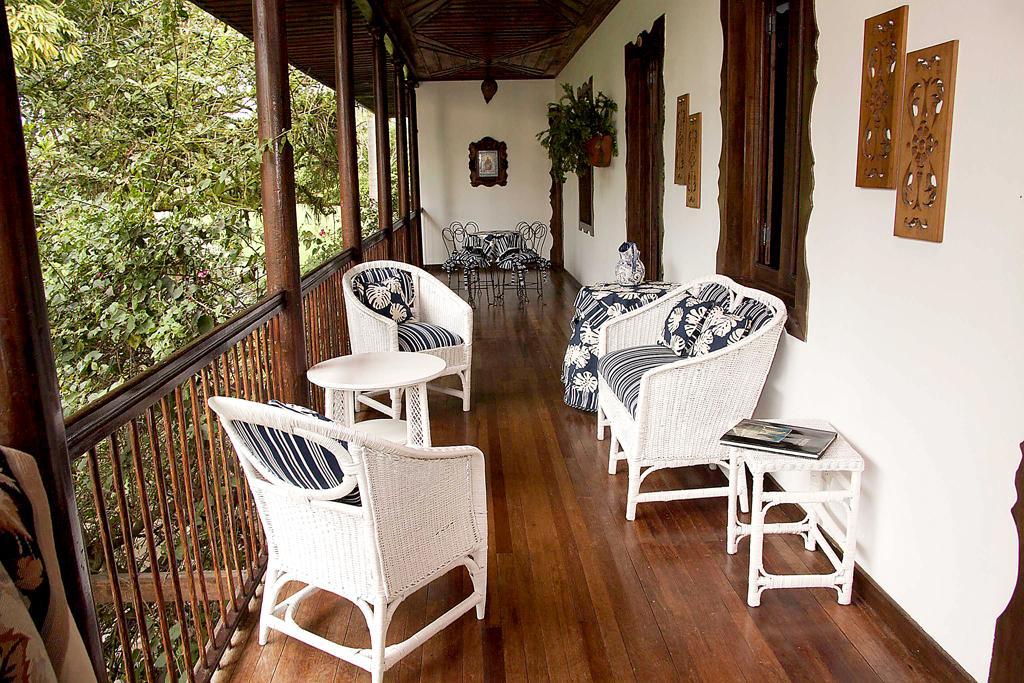Could you give a brief overview of what you see in this image? here in this picture we can see the balcony with a beautiful chair and frames on the wall,here we can also see the trees. 